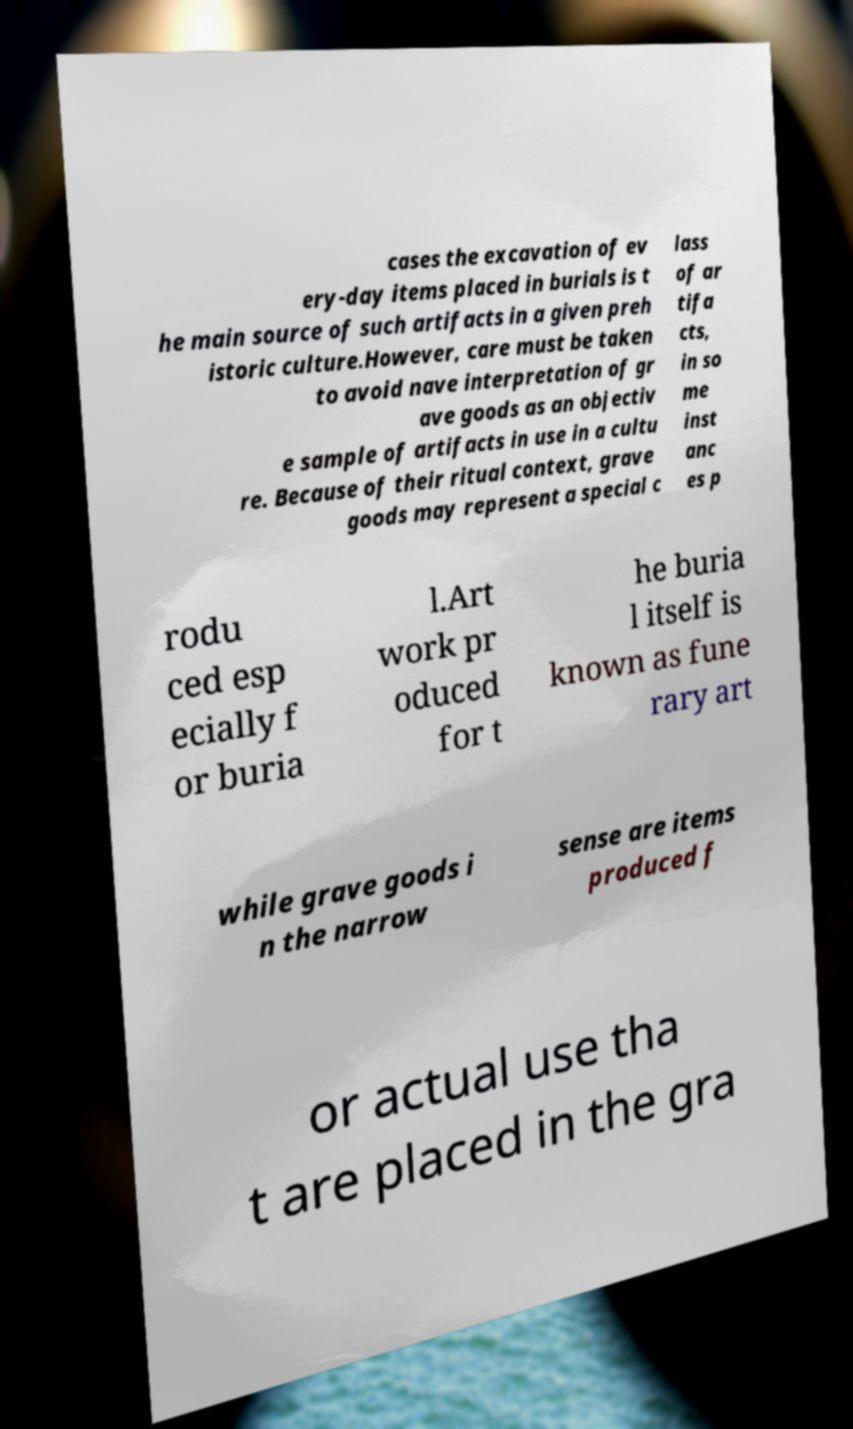Please identify and transcribe the text found in this image. cases the excavation of ev ery-day items placed in burials is t he main source of such artifacts in a given preh istoric culture.However, care must be taken to avoid nave interpretation of gr ave goods as an objectiv e sample of artifacts in use in a cultu re. Because of their ritual context, grave goods may represent a special c lass of ar tifa cts, in so me inst anc es p rodu ced esp ecially f or buria l.Art work pr oduced for t he buria l itself is known as fune rary art while grave goods i n the narrow sense are items produced f or actual use tha t are placed in the gra 